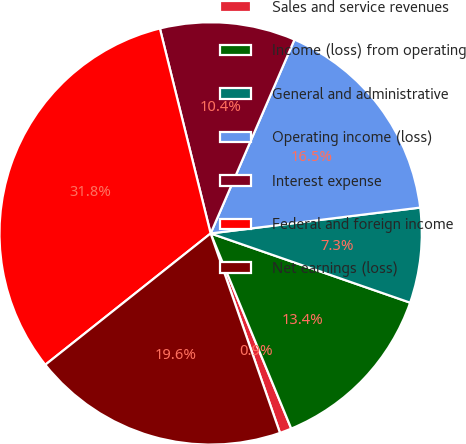<chart> <loc_0><loc_0><loc_500><loc_500><pie_chart><fcel>Sales and service revenues<fcel>Income (loss) from operating<fcel>General and administrative<fcel>Operating income (loss)<fcel>Interest expense<fcel>Federal and foreign income<fcel>Net earnings (loss)<nl><fcel>0.91%<fcel>13.45%<fcel>7.27%<fcel>16.55%<fcel>10.36%<fcel>31.82%<fcel>19.64%<nl></chart> 